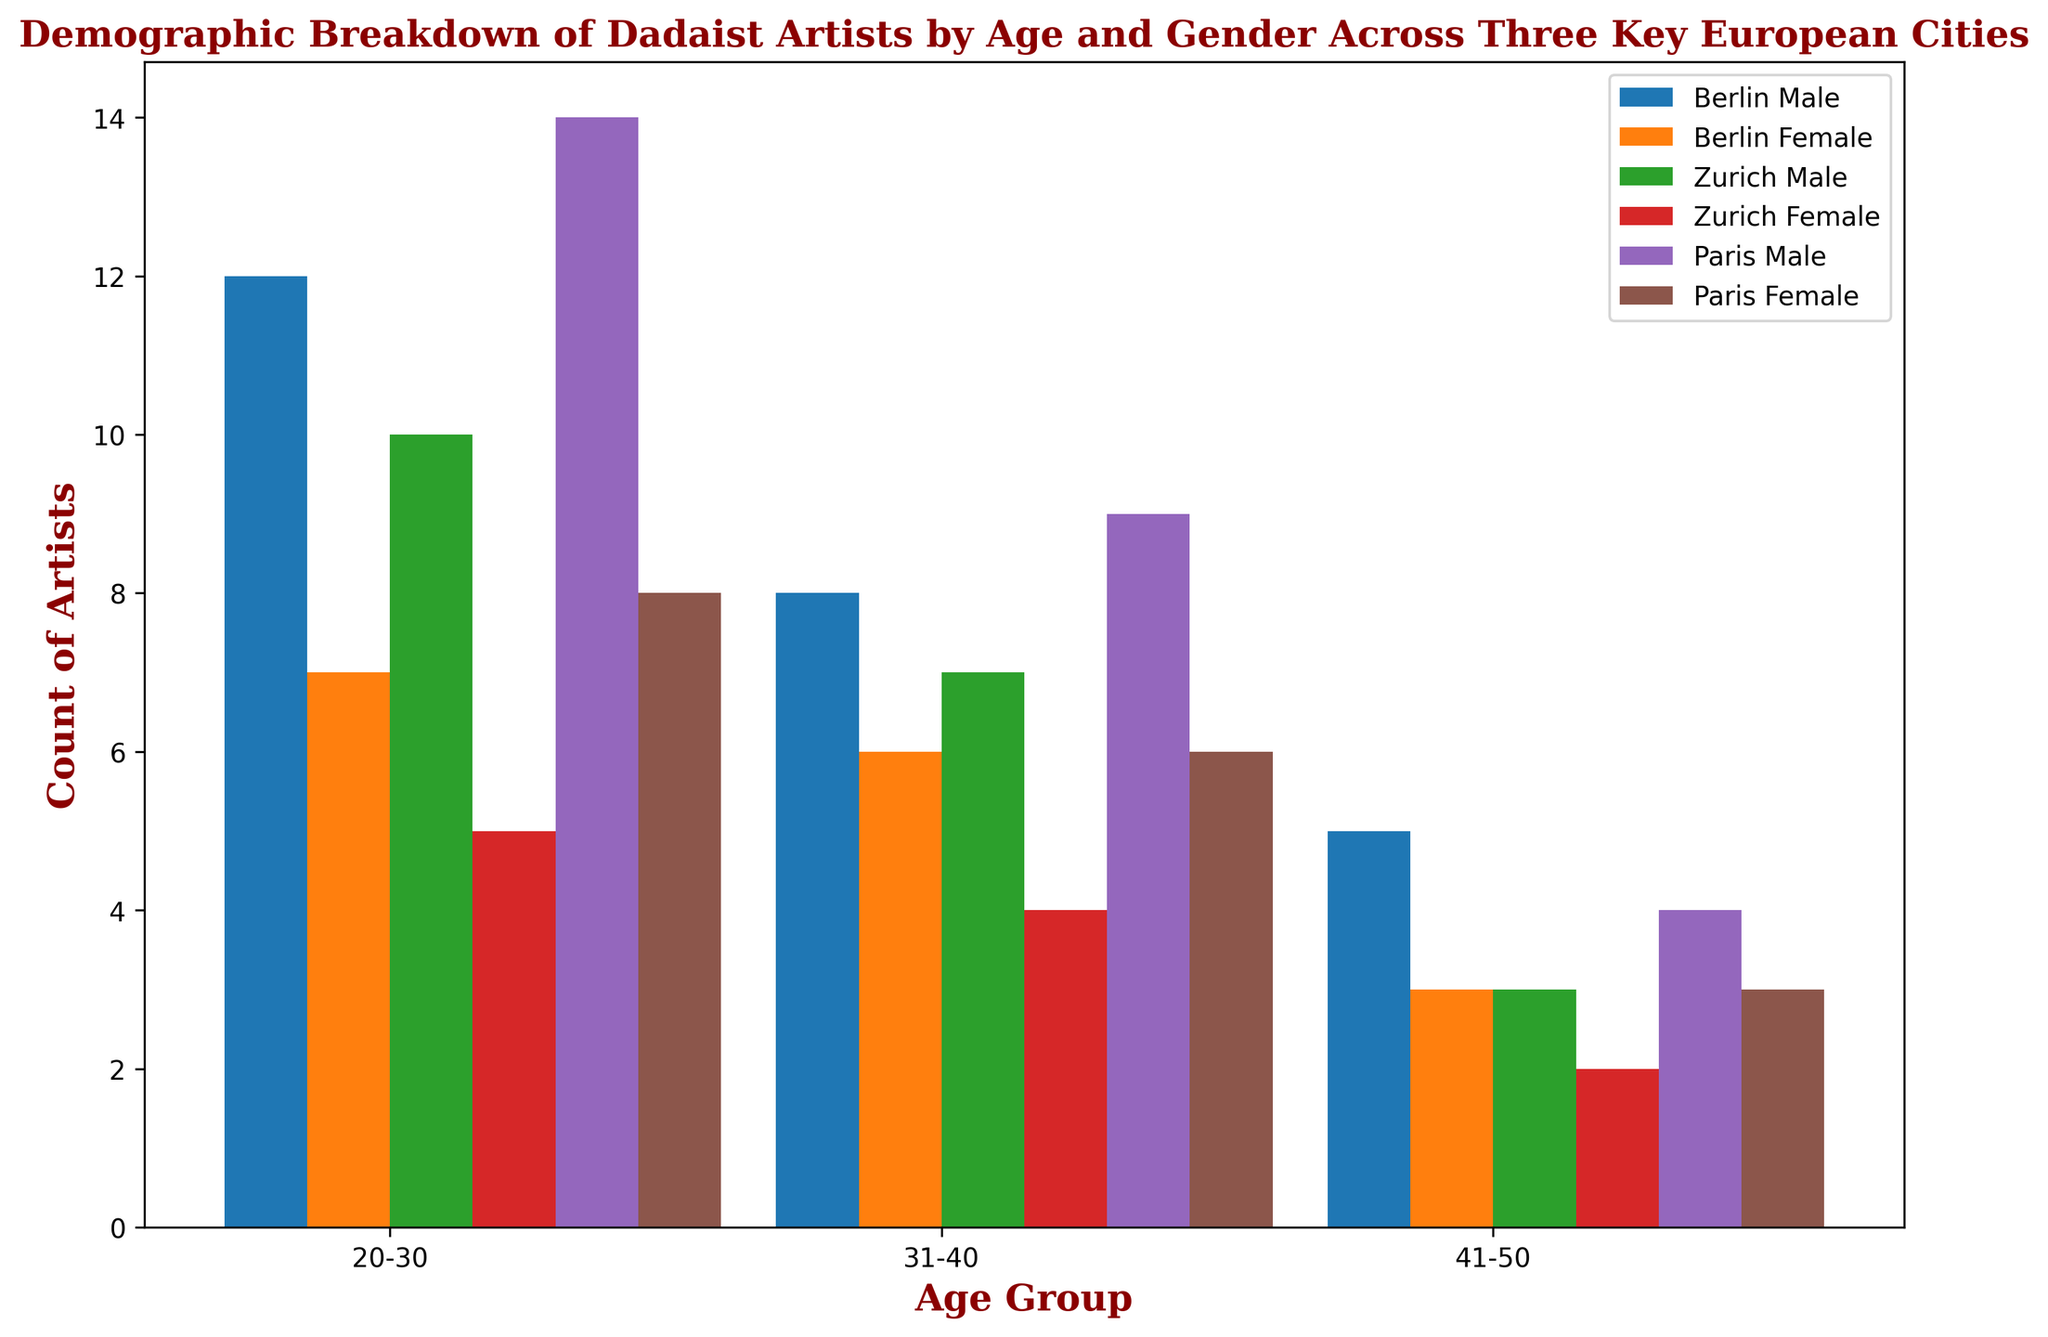Which city has the highest number of male artists in the 20-30 age group? By examining the height of the bars for the 20-30 age group across all cities, we see that Paris has the highest bar for male artists in this category.
Answer: Paris What is the total number of female artists from all cities in the 31-40 age group? We need to sum the counts of female artists in the 31-40 age group from Berlin (6), Zurich (4), and Paris (6). 6 + 4 + 6 = 16.
Answer: 16 Which gender has a higher number of artists in Zurich in the 41-50 age group? Comparing the height of bars for males and females in Zurich for the 41-50 age group, the bar for males is taller.
Answer: Male How many more male artists are there than female artists in Berlin's 20-30 age group? Subtract the count of female artists (7) from the count of male artists (12) in Berlin for the 20-30 age group. 12 - 7 = 5.
Answer: 5 Which age group has the smallest number of female artists in Paris? By comparing the height of the bars representing female artists in Paris across all age groups, we see that the 41-50 age group has the shortest bar.
Answer: 41-50 What is the total count of artists (both genders) in the 20-30 age group across all cities? Sum the counts of male and female artists in the 20-30 age group from all cities. For Berlin: 12 + 7 = 19, Zurich: 10 + 5 = 15, Paris: 14 + 8 = 22. Then add these sums: 19 + 15 + 22 = 56.
Answer: 56 Is the total number of artists in the 31-40 age group greater in Berlin or Zurich? Compare the total number of male and female artists combined in the 31-40 age group for Berlin (8 + 6 = 14) and Zurich (7 + 4 = 11). Berlin has more artists.
Answer: Berlin In which city is the gender disparity (difference between male and female artists) the greatest for the 41-50 age group? Calculate the difference between male and female artists in the 41-50 age group for all cities: Berlin (5 - 3 = 2), Zurich (3 - 2 = 1), Paris (4 - 3 = 1). Berlin has the greatest disparity.
Answer: Berlin 